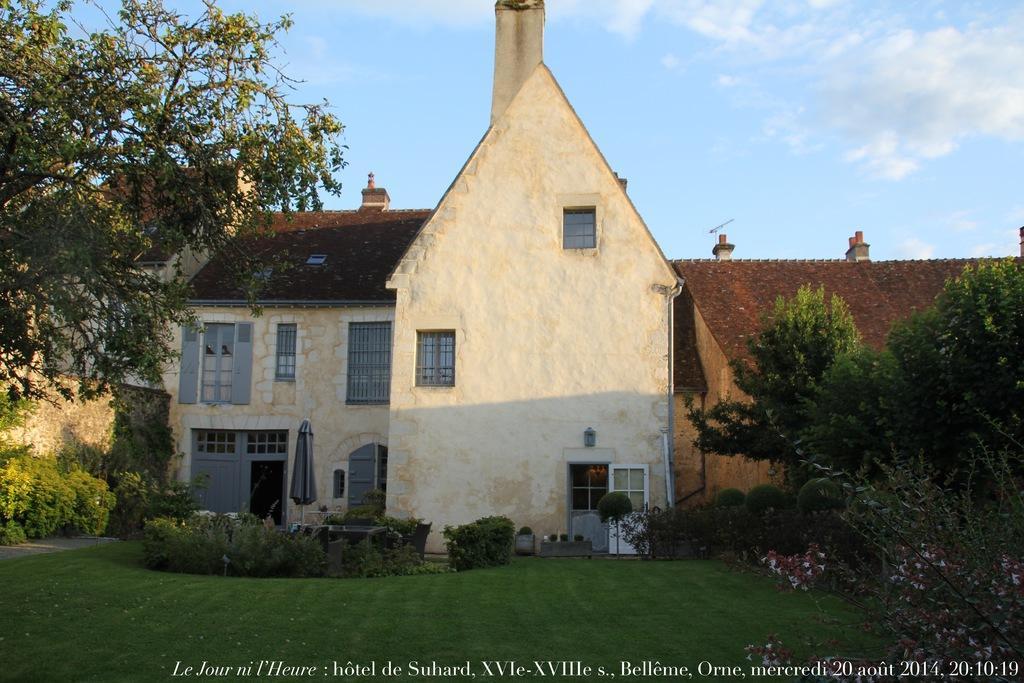Describe this image in one or two sentences. In this picture I can see the text at the bottom, in the middle there are trees, bushes and houses. At the top there is the sky. 